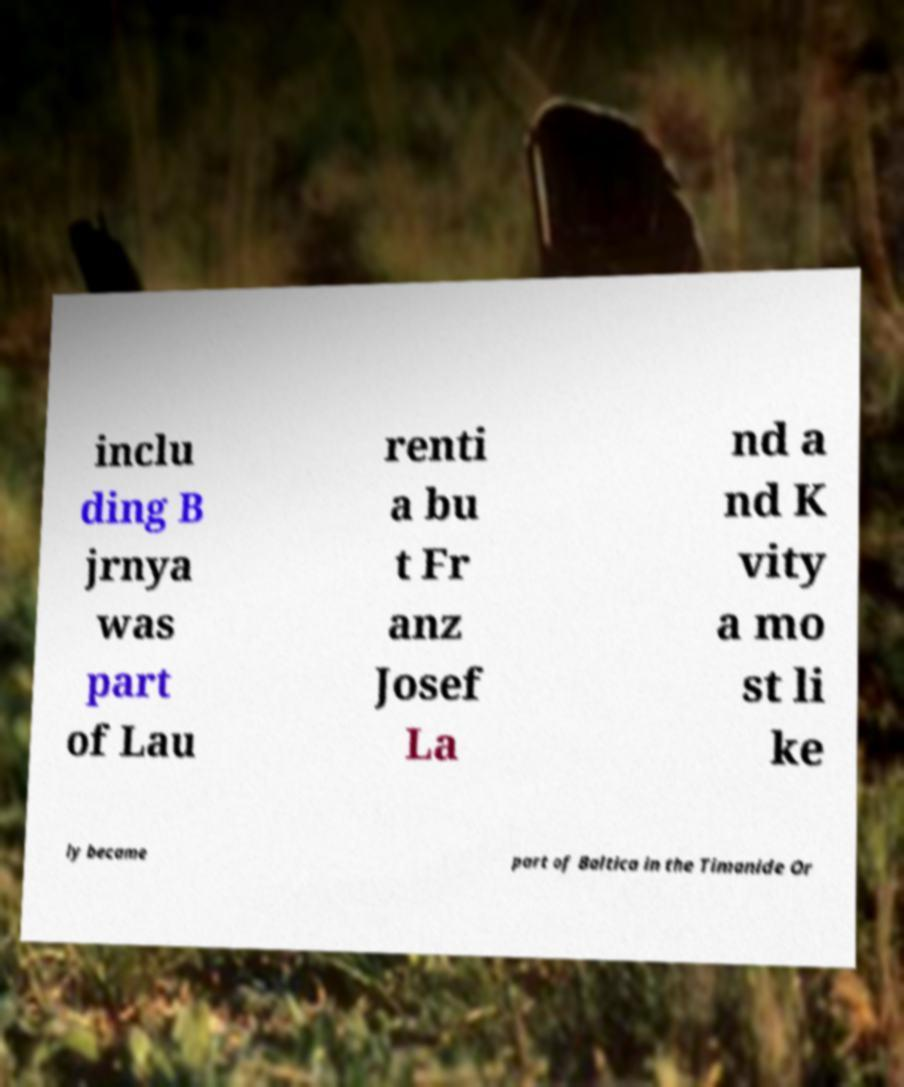Can you read and provide the text displayed in the image?This photo seems to have some interesting text. Can you extract and type it out for me? inclu ding B jrnya was part of Lau renti a bu t Fr anz Josef La nd a nd K vity a mo st li ke ly became part of Baltica in the Timanide Or 